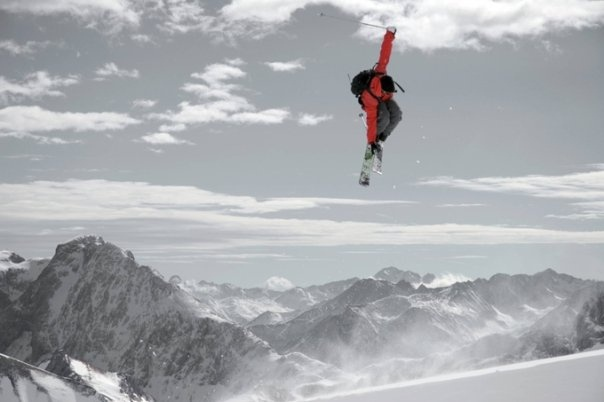Describe the objects in this image and their specific colors. I can see people in darkgray, black, brown, and maroon tones, skis in darkgray, gray, and lightgray tones, and backpack in darkgray, black, gray, and purple tones in this image. 